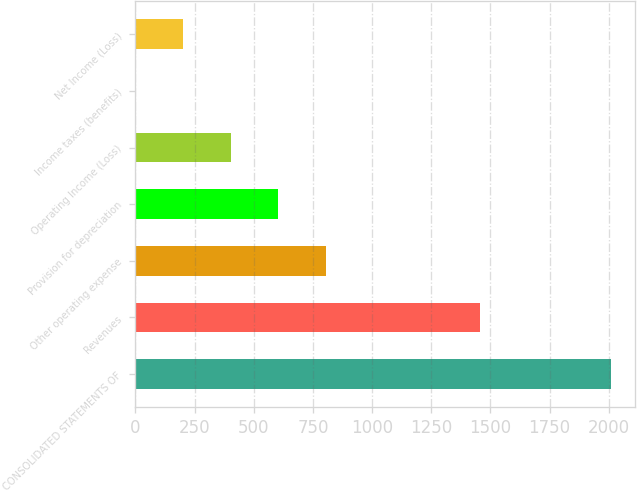Convert chart. <chart><loc_0><loc_0><loc_500><loc_500><bar_chart><fcel>CONSOLIDATED STATEMENTS OF<fcel>Revenues<fcel>Other operating expense<fcel>Provision for depreciation<fcel>Operating Income (Loss)<fcel>Income taxes (benefits)<fcel>Net Income (Loss)<nl><fcel>2012<fcel>1456<fcel>805.4<fcel>604.3<fcel>403.2<fcel>1<fcel>202.1<nl></chart> 